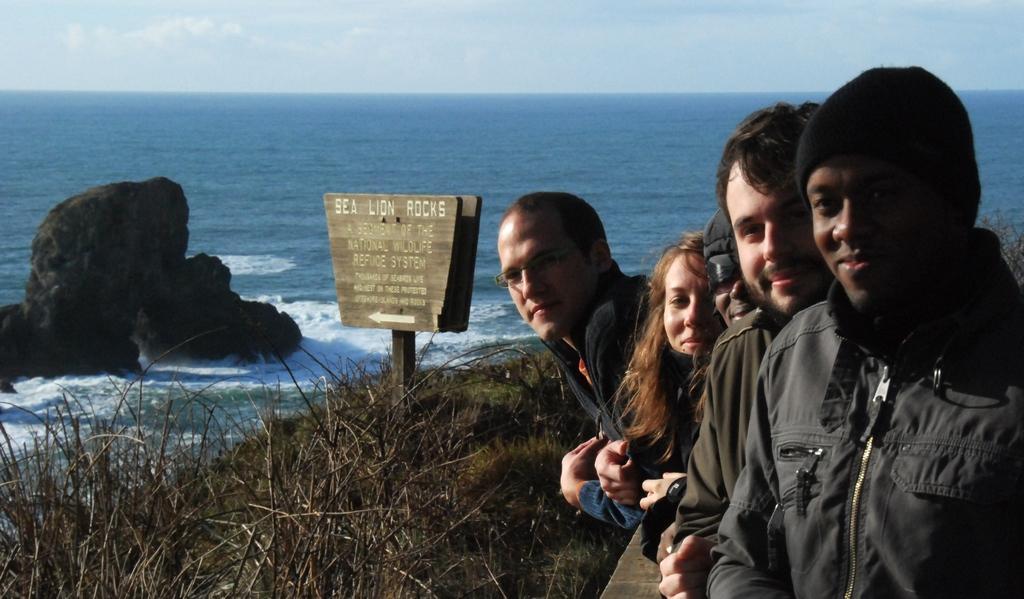Describe this image in one or two sentences. In this image we can see people standing and smiling. In the background there are rocks, sea, sign boards, grass and sky with clouds. 